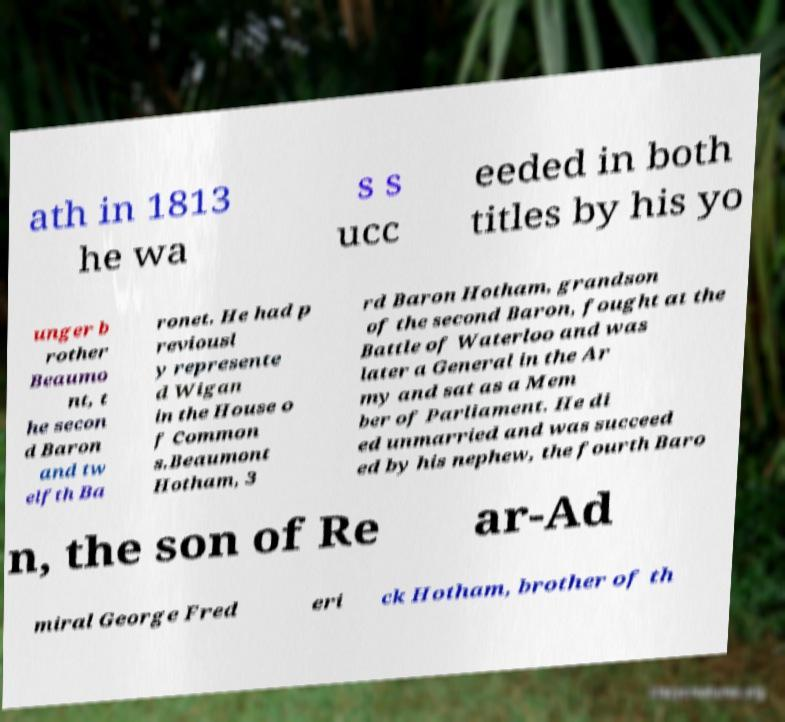There's text embedded in this image that I need extracted. Can you transcribe it verbatim? ath in 1813 he wa s s ucc eeded in both titles by his yo unger b rother Beaumo nt, t he secon d Baron and tw elfth Ba ronet. He had p reviousl y represente d Wigan in the House o f Common s.Beaumont Hotham, 3 rd Baron Hotham, grandson of the second Baron, fought at the Battle of Waterloo and was later a General in the Ar my and sat as a Mem ber of Parliament. He di ed unmarried and was succeed ed by his nephew, the fourth Baro n, the son of Re ar-Ad miral George Fred eri ck Hotham, brother of th 